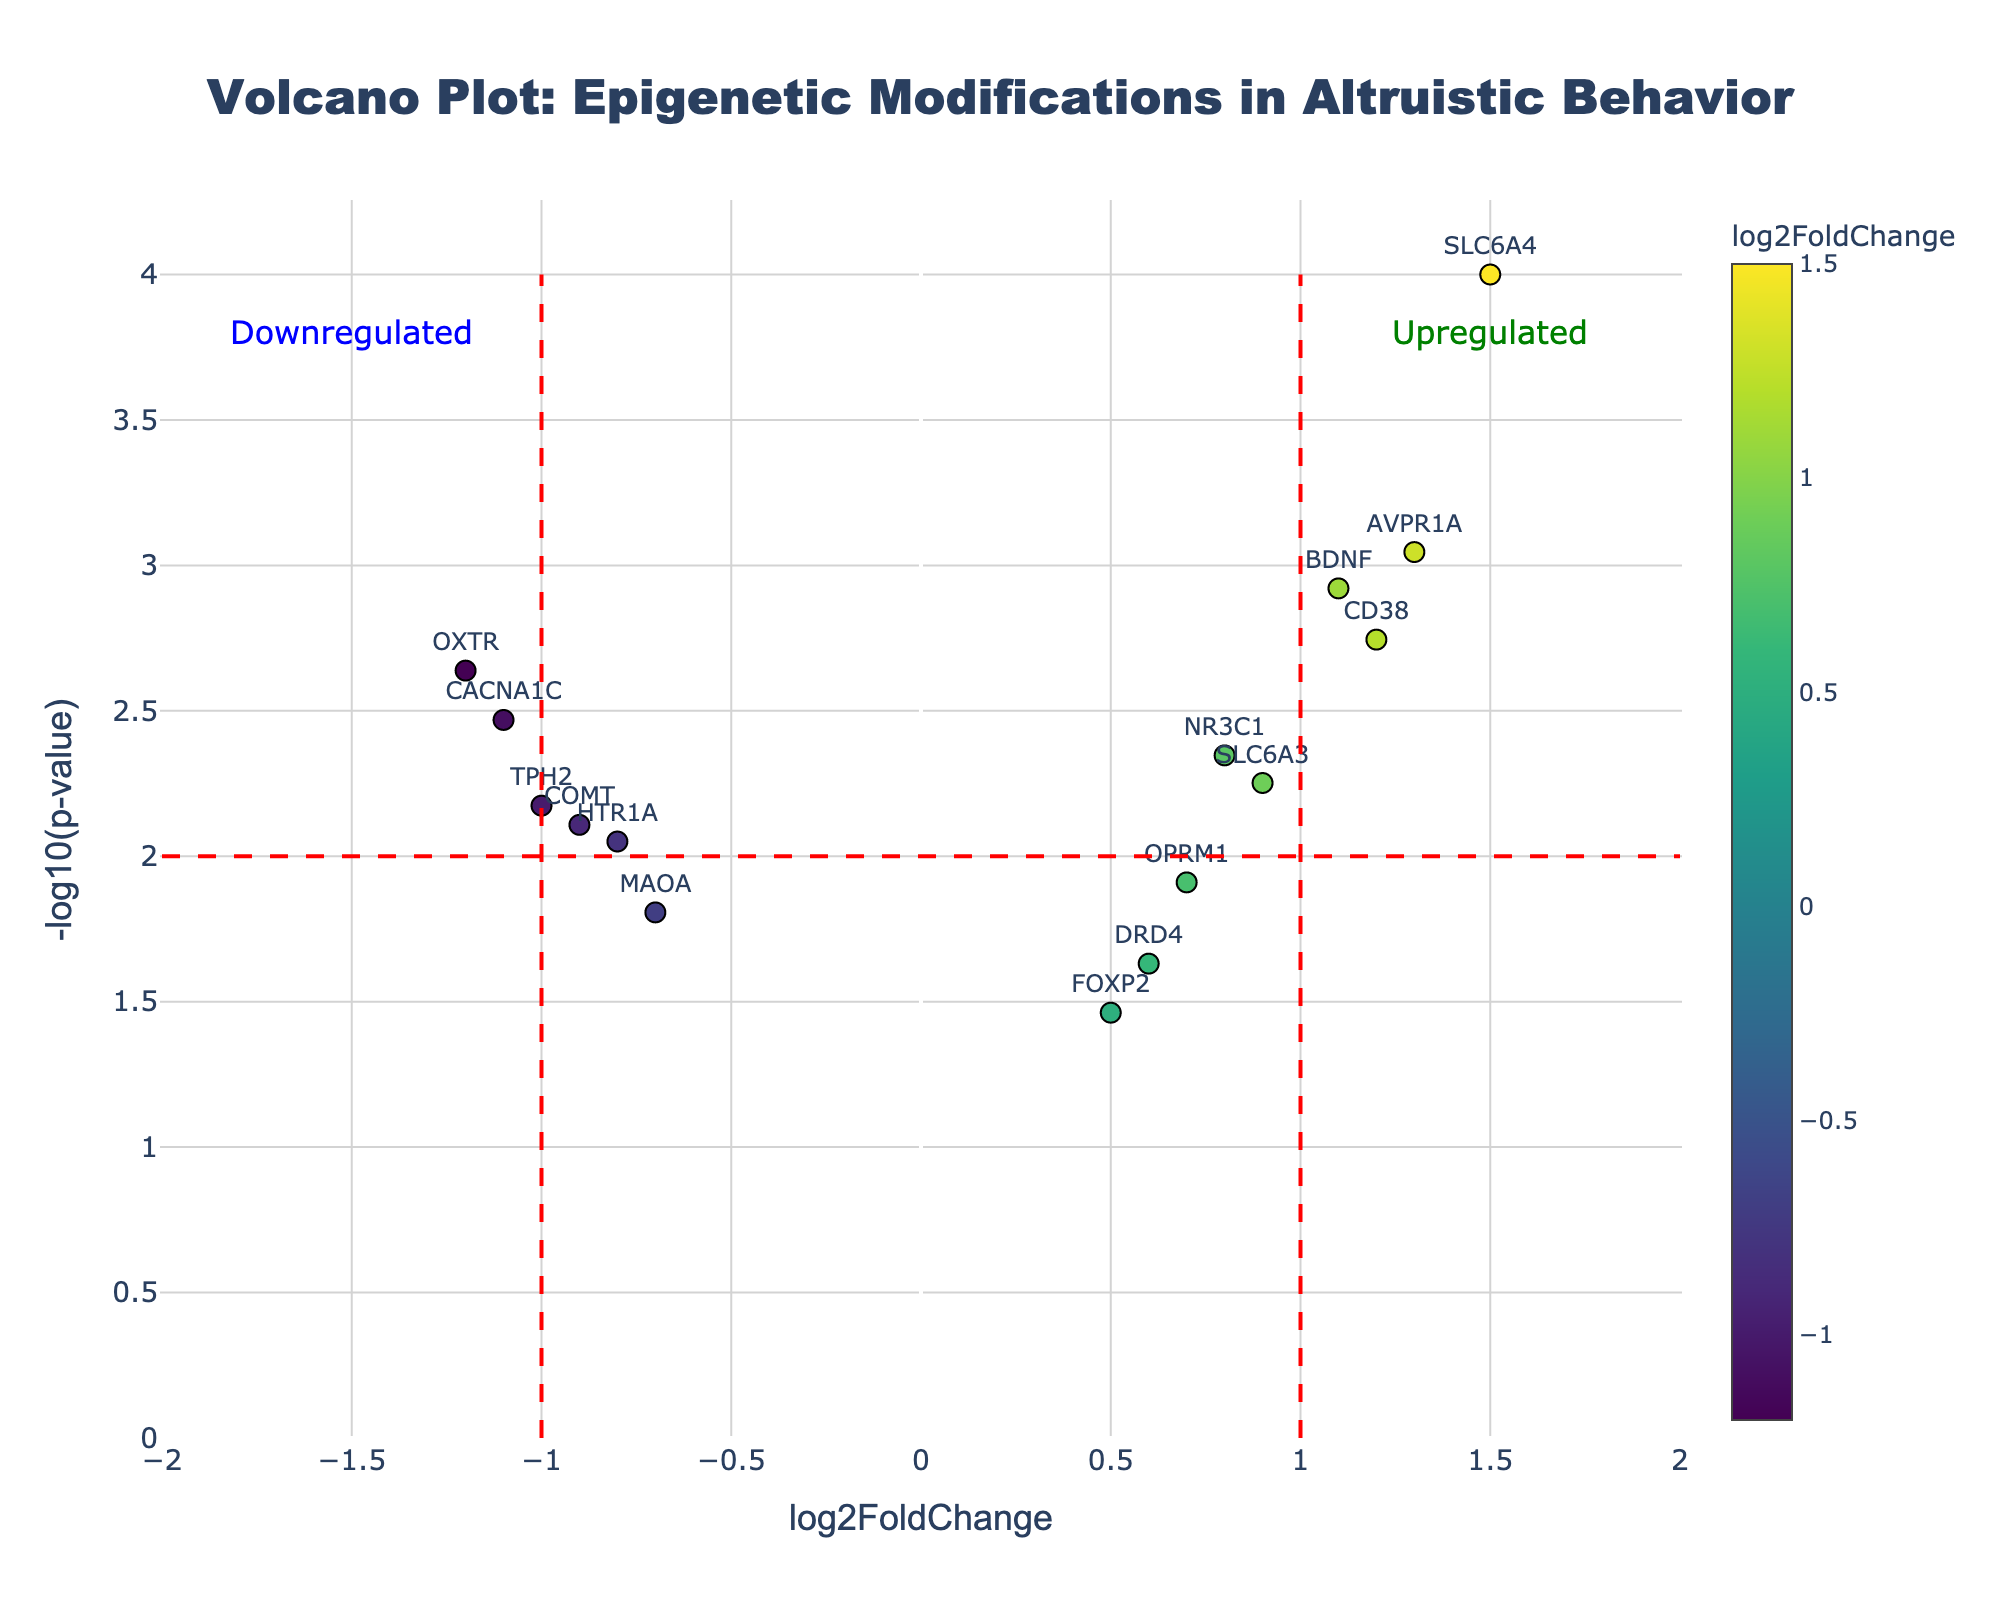Which gene has the highest -log10(p-value)? Look for the data point that is positioned highest on the y-axis of the plot. The gene with the highest -log10(p-value) is SLC6A4.
Answer: SLC6A4 What color represents upregulated genes? Upregulated genes have a positive log2FoldChange, and the colorbar shows a gradient. The green annotation indicates upregulated genes. Thus, upregulated genes are represented by colors on the positive side of the colorbar.
Answer: Colors on the positive side of the colorbar Which gene has the most negative log2FoldChange? Locate the gene farthest to the left on the x-axis, as this indicates the most negative log2FoldChange. The gene at that position is OXTR.
Answer: OXTR How many genes are significantly downregulated (log2FoldChange <= -1 and -log10(p-value) >= 2)? Identify genes on the left of the red vertical line at x = -1 and above the horizontal line at y = 2. The genes fitting this criteria are OXTR and CACNA1C.
Answer: 2 Which genes have a log2FoldChange greater than or equal to 1 and a -log10(p-value) greater than or equal to 3? Identify genes on or to the right of the red vertical line at x = 1 and above y = 3. The genes are SLC6A4, BDNF, AVPR1A, and CD38.
Answer: SLC6A4, AVPR1A, and CD38 What is the difference in log2FoldChange between SLC6A4 and COMT? SLC6A4 has a log2FoldChange of 1.5, and COMT has a log2FoldChange of -0.9. The difference is 1.5 - (-0.9) = 1.5 + 0.9 = 2.4.
Answer: 2.4 Which gene is just below the threshold for statistical significance with a log2FoldChange of approximately 0.5? Identify the gene with a log2FoldChange near 0.5 and check if its -log10(p-value) is just below the horizontal significance line. The gene is FOXP2.
Answer: FOXP2 How many genes are labeled as "Upregulated" in the plot? Count the data points in the red box, to the right of log2FoldChange = 1, and above the threshold. The figure shows 4 genes in this category.
Answer: 4 What is the percentage of upregulated genes in the plot? There are 15 total genes. 6 genes (SLC6A4, NR3C1, BDNF, AVPR1A, CD38, SLC6A3) are upregulated (log2FoldChange > 0). Calculate 6/15 * 100% = 40%.
Answer: 40% Compare the significance of COMT and TPH2 in terms of p-value. Which one is more significant? Compare the -log10(p-value) values by observing their y-axis positions. TPH2 is higher than COMT on the y-axis, meaning TPH2 has a lower p-value and is more significant.
Answer: TPH2 